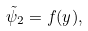Convert formula to latex. <formula><loc_0><loc_0><loc_500><loc_500>\tilde { \psi } _ { 2 } = f ( y ) ,</formula> 